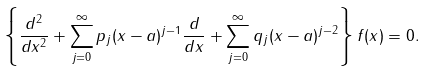Convert formula to latex. <formula><loc_0><loc_0><loc_500><loc_500>\left \{ \frac { d ^ { 2 } } { d x ^ { 2 } } + \sum _ { j = 0 } ^ { \infty } p _ { j } ( x - a ) ^ { j - 1 } \frac { d } { d x } + \sum _ { j = 0 } ^ { \infty } q _ { j } ( x - a ) ^ { j - 2 } \right \} f ( x ) = 0 .</formula> 